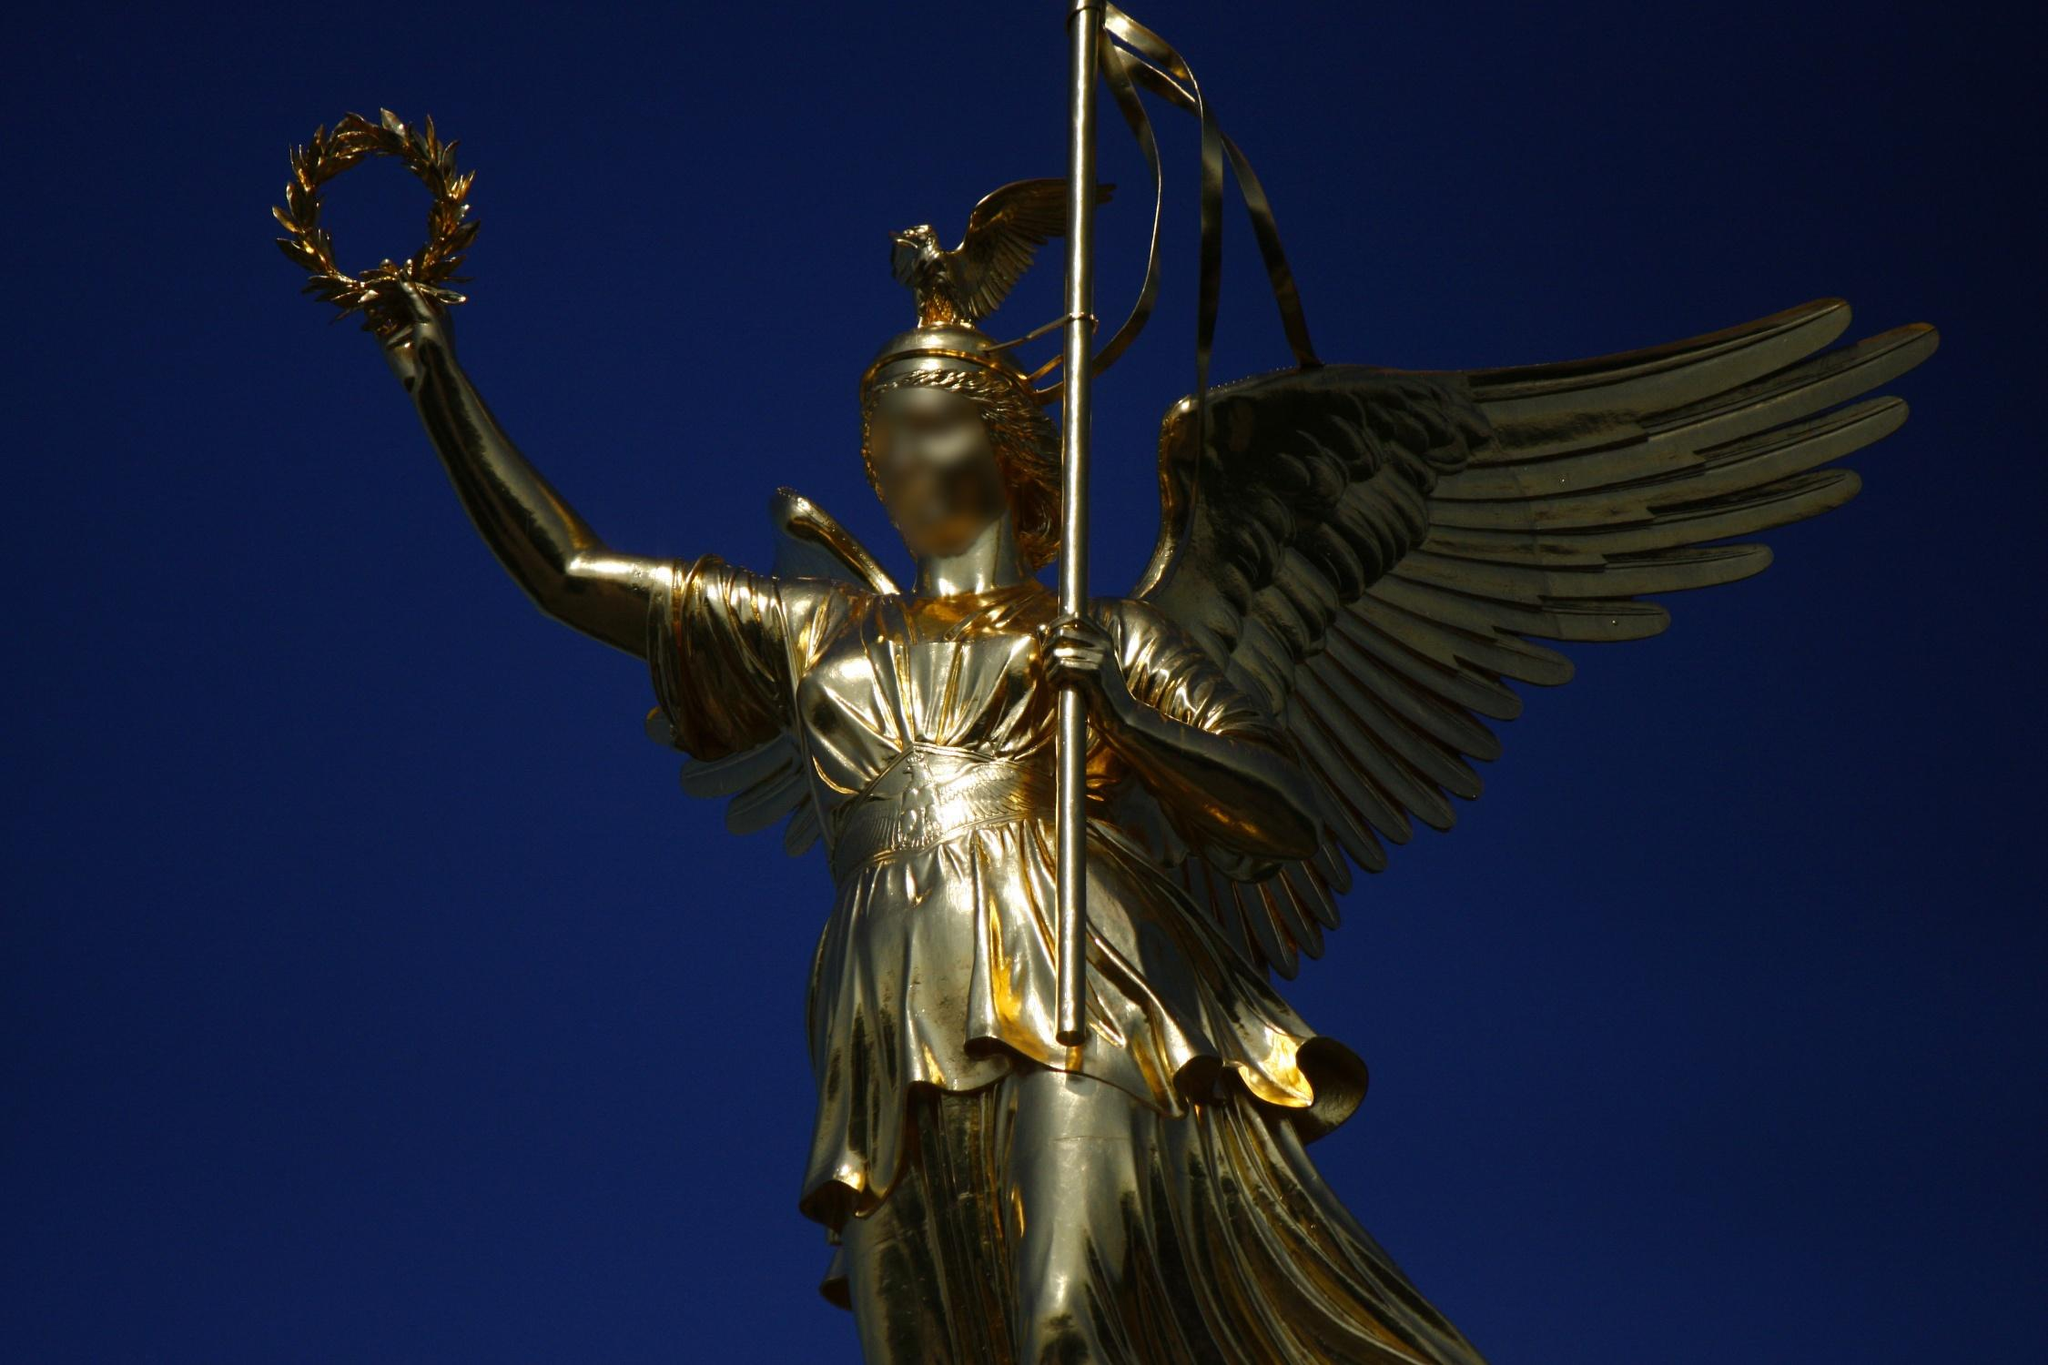Imagine this statue comes to life. What would be its first actions and words? If the statue of Victoria atop the Victory Column were to come to life, she would unfurl her golden wings, casting a brilliant light over Berlin. Her first words, spoken in a voice resounding with ancient wisdom and modern resolve, might be: 'Rise, people of this great city, and let your spirits soar as high as mine. Together, we shall overcome any challenge, just as we have triumphed in the past.' With a graceful yet commanding presence, she might direct her laurel wreath towards landmarks of the city, commemorating their historical significance while inspiring the citizens to strive for new victories. Create a short conversational piece as if Victoria, the Roman goddess, is explaining the purpose of her statue to a curious visitor. Visitor: 'Victoria, your statue is magnificent. What purpose does it serve?'
Victoria: 'Thank you, kind soul. This statue celebrates the victories of the people of this land. It honors their courage, their sacrifices, and their unwavering spirit in the face of adversity. Standing here, I watch over them, reminding them of the glory that comes from unity and strength. May it inspire every visitor to strive for greatness and to cherish the victories, both great and small, in their own lives.' 